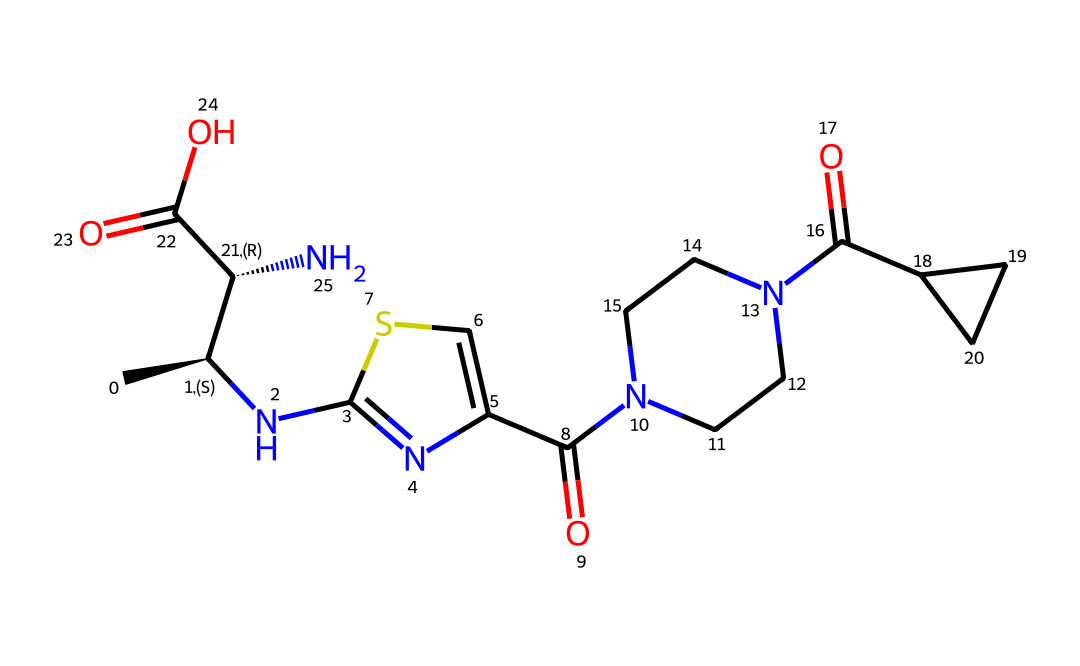What is the total number of nitrogen atoms in this chemical? Upon inspecting the SMILES representation, there are two nitrogen atoms indicated by "N" in the structure.
Answer: 2 How many chiral centers are present in this chemical? The SMILES indicates two chiral centers denoted by "[C@H]", which indicates that stereochemistry is present at those specific carbon atoms.
Answer: 2 What is the molecular weight of this drug? The total of all atoms in the structural formula (C, H, N, O, S) gives a molecular weight of approximately 337.40 g/mol. However, exact calculations should rely on detailed atom counts and their respective atomic weights.
Answer: approximately 337.40 g/mol Which functional groups are present in this chemical? The presence of amides (C(=O)N), carboxylic acid (C(=O)O), and thiophene (the 'cs' part suggests a sulfur-containing ring) indicates multiple functional groups in the structure.
Answer: amides, carboxylic acid, thiophene What classification can this drug belong to based on its structure? Given the presence of a heterocyclic ring, amide and carboxylic acid functional groups, this compound likely qualifies as a peptide or an alkaloid, which are typical for drugs.
Answer: peptide or alkaloid How many rings are present in this chemical structure? By examining the SMILES notation, there is one ring present, as indicated by the "c" characters showing a part of a cyclic compound.
Answer: 1 What is the possible route of metabolism for this drug? The presence of functional groups such as amides suggests that the drug could undergo hydrolysis in the liver, reflecting a common metabolic pathway for many medications.
Answer: hydrolysis 